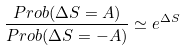<formula> <loc_0><loc_0><loc_500><loc_500>\frac { P r o b ( \Delta S = A ) } { P r o b ( \Delta S = - A ) } \simeq e ^ { \Delta S }</formula> 